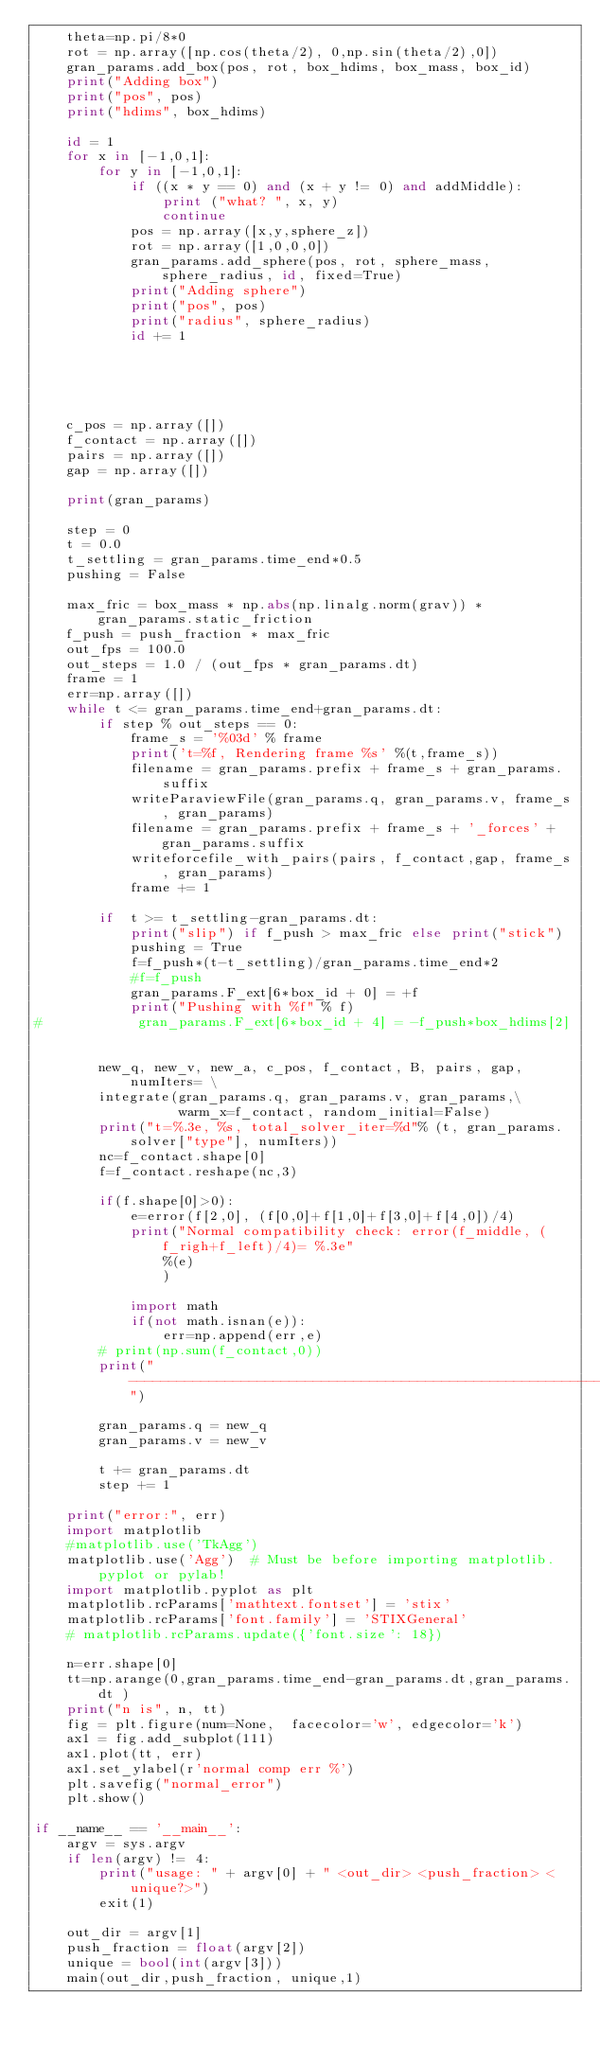Convert code to text. <code><loc_0><loc_0><loc_500><loc_500><_Python_>    theta=np.pi/8*0
    rot = np.array([np.cos(theta/2), 0,np.sin(theta/2),0])
    gran_params.add_box(pos, rot, box_hdims, box_mass, box_id)
    print("Adding box")
    print("pos", pos)
    print("hdims", box_hdims)

    id = 1
    for x in [-1,0,1]:
        for y in [-1,0,1]:
            if ((x * y == 0) and (x + y != 0) and addMiddle):
                print ("what? ", x, y)
                continue
            pos = np.array([x,y,sphere_z])
            rot = np.array([1,0,0,0])
            gran_params.add_sphere(pos, rot, sphere_mass, sphere_radius, id, fixed=True)
            print("Adding sphere")
            print("pos", pos)
            print("radius", sphere_radius)
            id += 1





    c_pos = np.array([])
    f_contact = np.array([])
    pairs = np.array([])
    gap = np.array([])

    print(gran_params)

    step = 0
    t = 0.0
    t_settling = gran_params.time_end*0.5
    pushing = False

    max_fric = box_mass * np.abs(np.linalg.norm(grav)) * gran_params.static_friction
    f_push = push_fraction * max_fric
    out_fps = 100.0
    out_steps = 1.0 / (out_fps * gran_params.dt)
    frame = 1
    err=np.array([])
    while t <= gran_params.time_end+gran_params.dt:
        if step % out_steps == 0:
            frame_s = '%03d' % frame
            print('t=%f, Rendering frame %s' %(t,frame_s))
            filename = gran_params.prefix + frame_s + gran_params.suffix
            writeParaviewFile(gran_params.q, gran_params.v, frame_s, gran_params)
            filename = gran_params.prefix + frame_s + '_forces' + gran_params.suffix
            writeforcefile_with_pairs(pairs, f_contact,gap, frame_s, gran_params)
            frame += 1

        if  t >= t_settling-gran_params.dt:
            print("slip") if f_push > max_fric else print("stick")
            pushing = True
            f=f_push*(t-t_settling)/gran_params.time_end*2
            #f=f_push
            gran_params.F_ext[6*box_id + 0] = +f
            print("Pushing with %f" % f)
#            gran_params.F_ext[6*box_id + 4] = -f_push*box_hdims[2]


        new_q, new_v, new_a, c_pos, f_contact, B, pairs, gap, numIters= \
        integrate(gran_params.q, gran_params.v, gran_params,\
                  warm_x=f_contact, random_initial=False)
        print("t=%.3e, %s, total_solver_iter=%d"% (t, gran_params.solver["type"], numIters))
        nc=f_contact.shape[0]
        f=f_contact.reshape(nc,3)

        if(f.shape[0]>0):
            e=error(f[2,0], (f[0,0]+f[1,0]+f[3,0]+f[4,0])/4)
            print("Normal compatibility check: error(f_middle, (f_righ+f_left)/4)= %.3e"
                %(e)
                )

            import math
            if(not math.isnan(e)):
                err=np.append(err,e)
        # print(np.sum(f_contact,0))
        print("----------------------------------------------------------------")

        gran_params.q = new_q
        gran_params.v = new_v

        t += gran_params.dt
        step += 1

    print("error:", err)
    import matplotlib
    #matplotlib.use('TkAgg')
    matplotlib.use('Agg')  # Must be before importing matplotlib.pyplot or pylab!
    import matplotlib.pyplot as plt
    matplotlib.rcParams['mathtext.fontset'] = 'stix'
    matplotlib.rcParams['font.family'] = 'STIXGeneral'
    # matplotlib.rcParams.update({'font.size': 18})

    n=err.shape[0]
    tt=np.arange(0,gran_params.time_end-gran_params.dt,gran_params.dt )
    print("n is", n, tt)
    fig = plt.figure(num=None,  facecolor='w', edgecolor='k')
    ax1 = fig.add_subplot(111)
    ax1.plot(tt, err)
    ax1.set_ylabel(r'normal comp err %')
    plt.savefig("normal_error")
    plt.show()

if __name__ == '__main__':
    argv = sys.argv
    if len(argv) != 4:
        print("usage: " + argv[0] + " <out_dir> <push_fraction> <unique?>")
        exit(1)

    out_dir = argv[1]
    push_fraction = float(argv[2])
    unique = bool(int(argv[3]))
    main(out_dir,push_fraction, unique,1)
</code> 